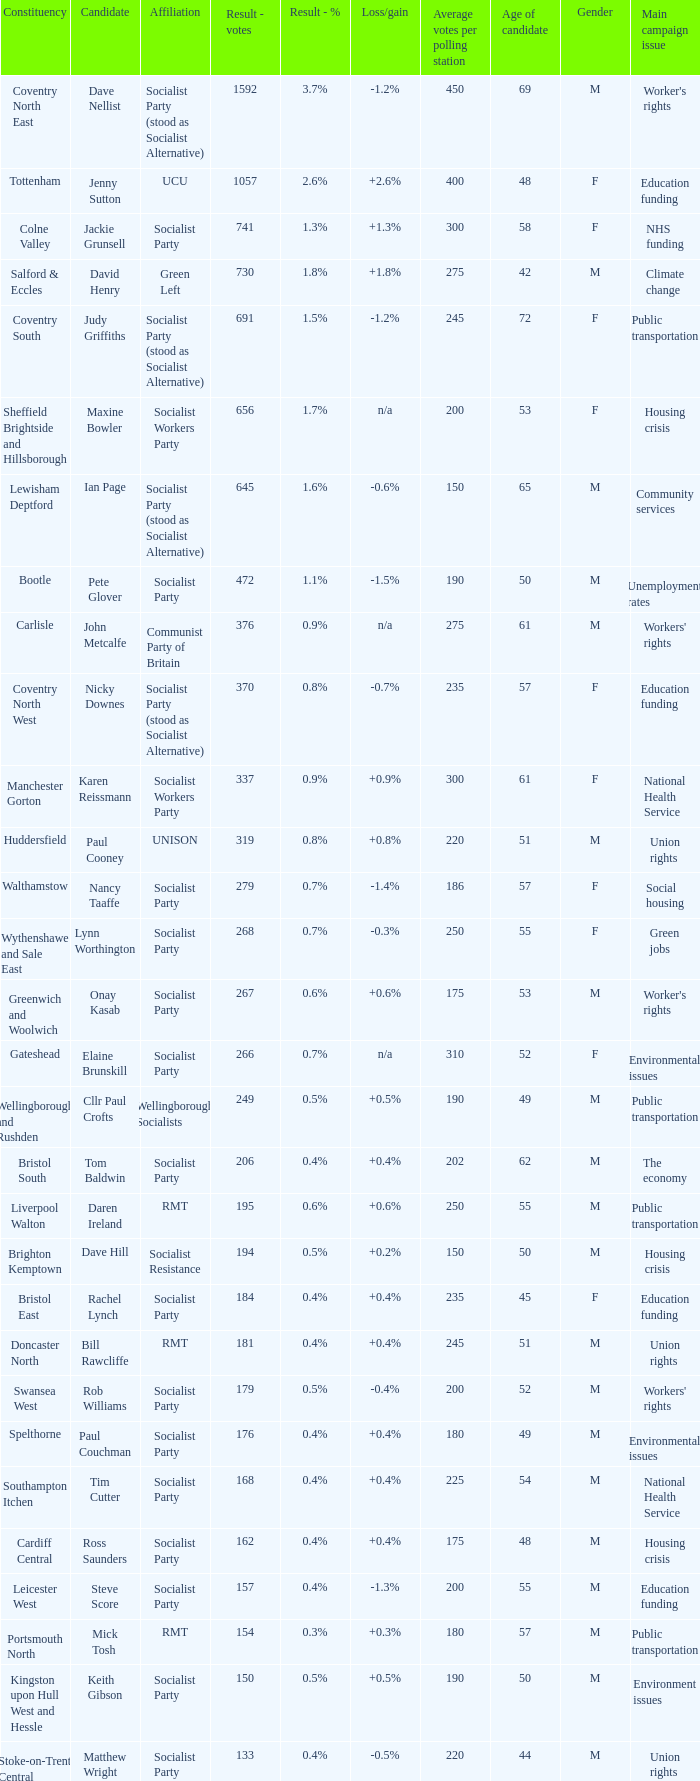How many values for constituency for the vote result of 162? 1.0. 